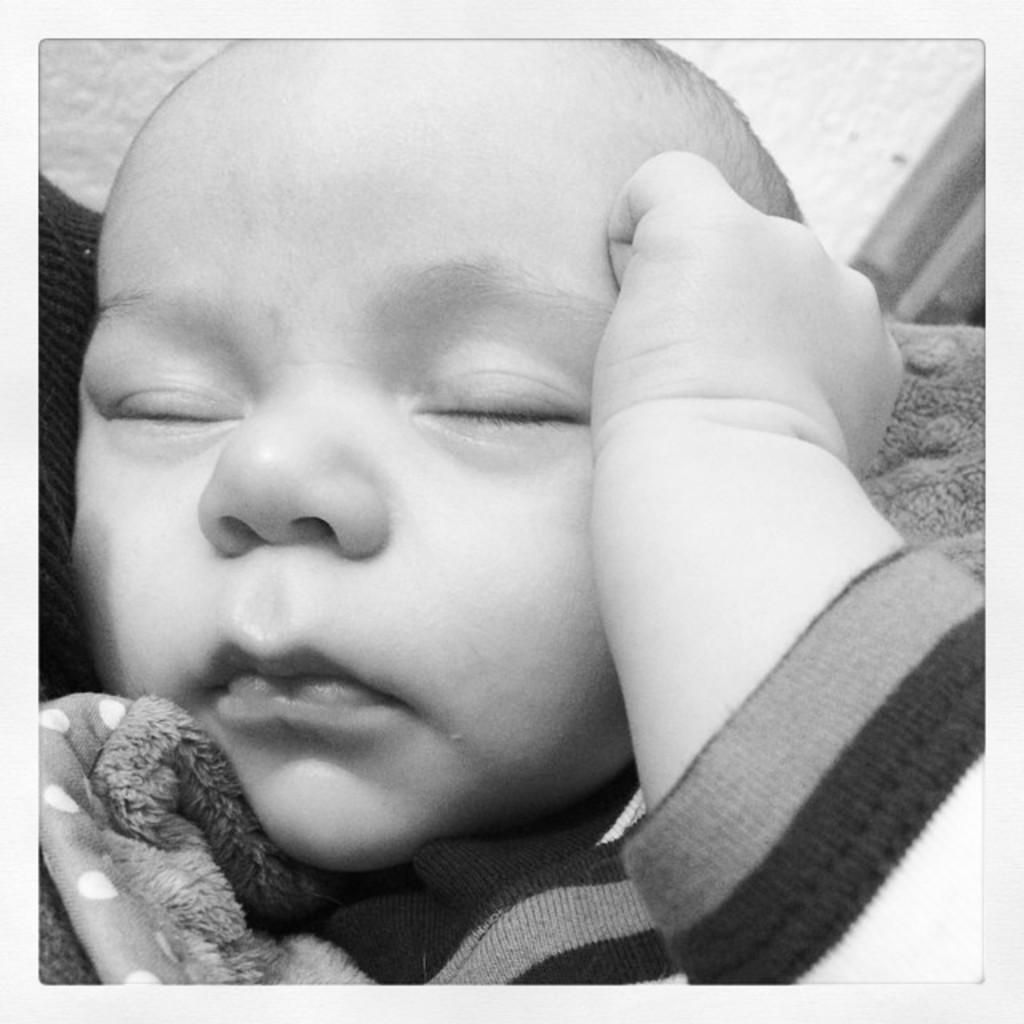What is the color scheme of the image? The image is black and white. What is the main subject of the image? There is a baby in the image. What is the baby wearing in the image? The baby is wearing clothes. How many times does the baby twist in the image? There is no indication of the baby twisting in the image, as it is a still photograph. Can you tell me how many months old the baby is in the image? The age of the baby cannot be determined from the image alone, as there is no information about the baby's age provided. 